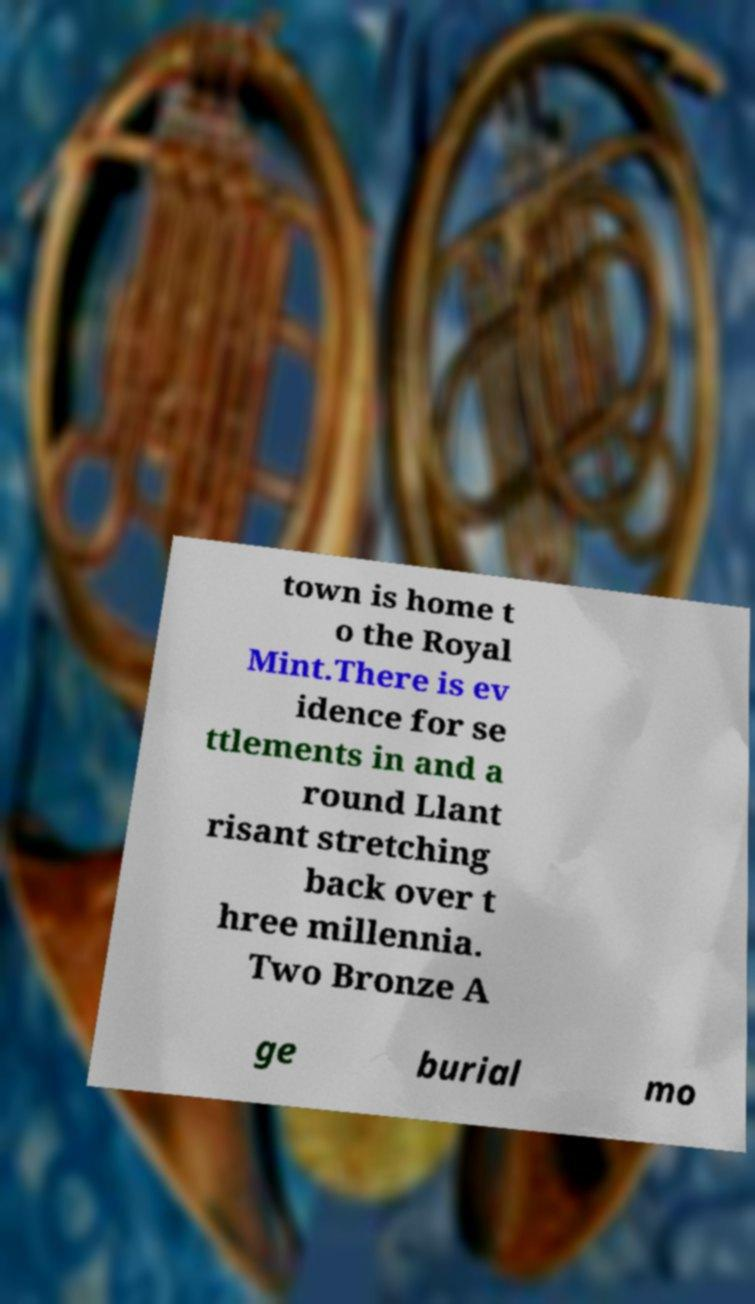Could you extract and type out the text from this image? town is home t o the Royal Mint.There is ev idence for se ttlements in and a round Llant risant stretching back over t hree millennia. Two Bronze A ge burial mo 